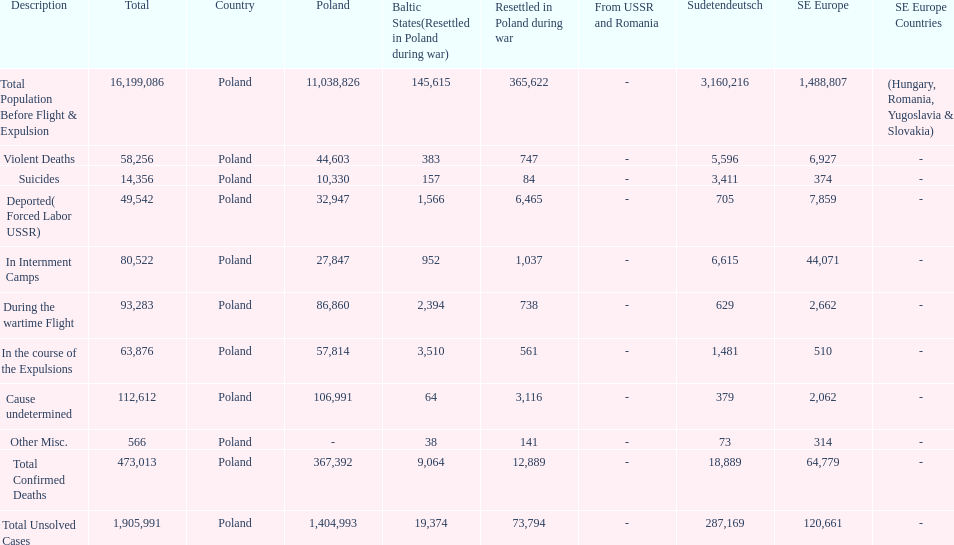What is the total number of violent deaths across all regions? 58,256. 